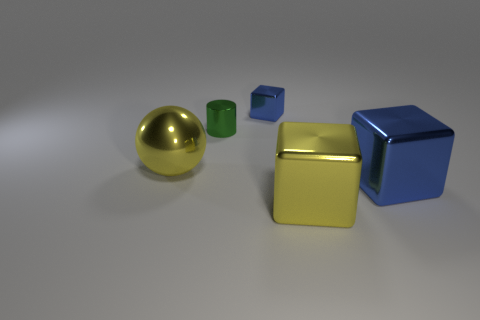If these objects had symbolic meaning, what could they represent? Symbolically, the objects could represent a variety of concepts. For instance, the ball could symbolize wholeness or unity due to its perfect shape. The green cube could stand for growth or nature given its color and solidity. The blue cube might represent stability or trust, and the golden cube might denote wealth or value. In combination, these objects might evoke a sense of diversity and harmony in differences. 